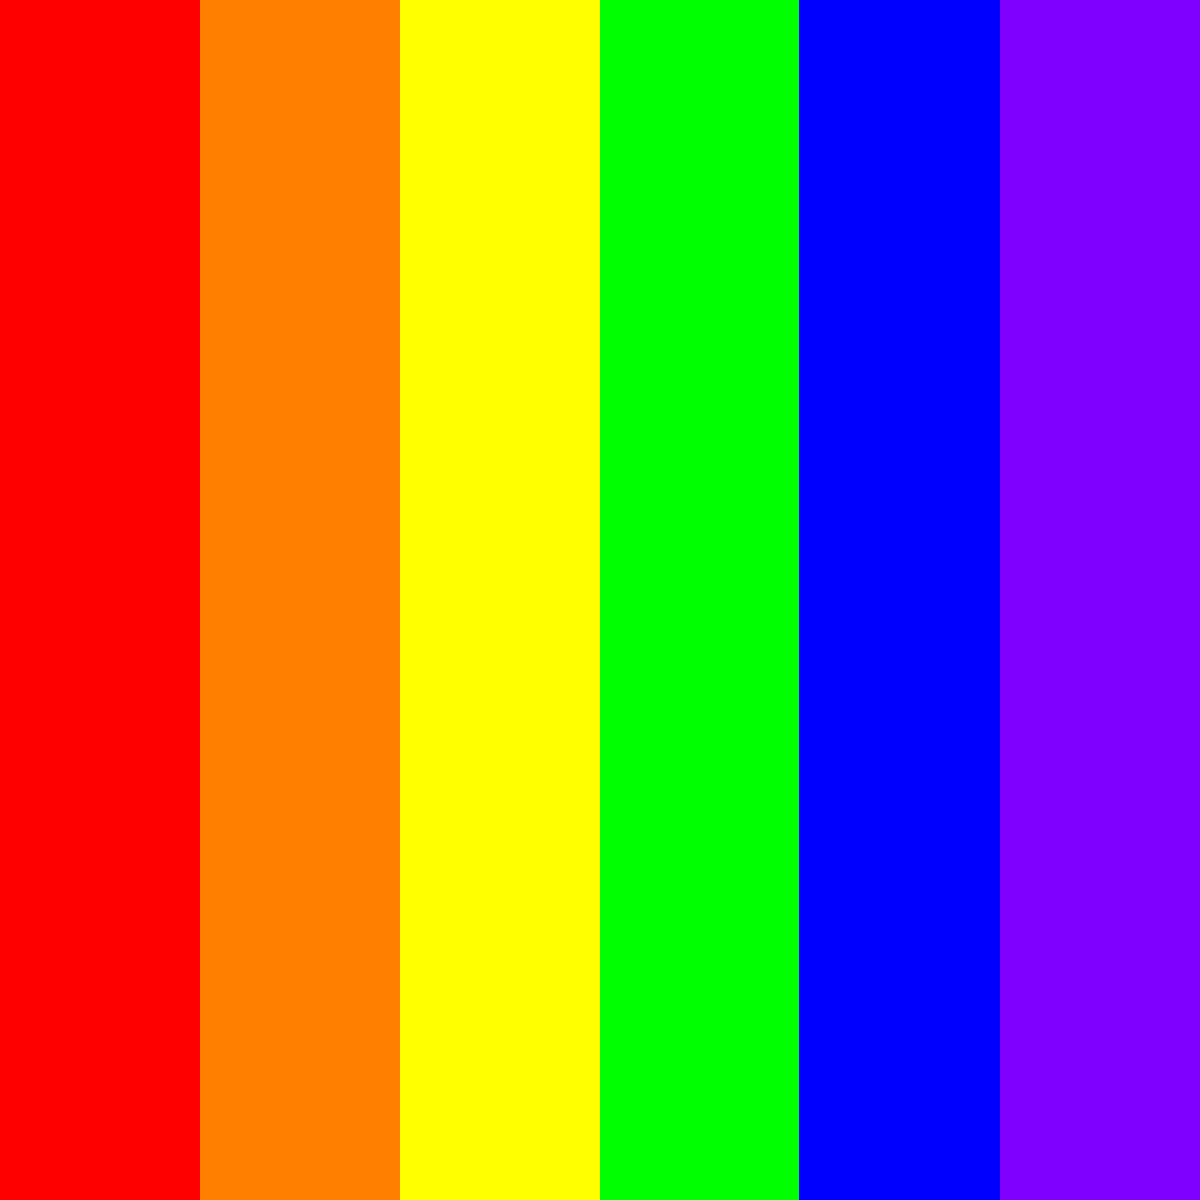In this vibrantly colored heat exchanger diagram, how does the thermal gradient relate to the pop art-inspired color scheme? Explain the relationship between color transitions and heat transfer efficiency. To understand the relationship between the color scheme and thermal gradient in this pop art-inspired heat exchanger diagram:

1. Color representation:
   - The colors transition from red (hot) to purple (cold)
   - Each color represents a temperature range in the heat exchanger

2. Thermal gradient analysis:
   - The diagram shows a continuous color spectrum, implying a smooth temperature transition
   - The gradient moves from left (hot) to right (cold)

3. Heat transfer efficiency:
   - More color bands indicate a larger temperature difference between hot and cold sides
   - A larger temperature difference generally leads to more efficient heat transfer

4. Pop art influence:
   - The use of bold, vibrant colors is characteristic of pop art
   - The distinct color bands create a visually striking representation of the thermal gradient

5. Efficiency interpretation:
   - Smooth color transitions suggest efficient heat transfer with minimal thermal resistance
   - Abrupt color changes would indicate potential areas of inefficiency or thermal barriers

In this case, the smooth transition through six distinct colors (red, orange, yellow, green, blue, purple) suggests a well-designed heat exchanger with efficient heat transfer characteristics.
Answer: The color transitions from red to purple represent decreasing temperatures, with smooth gradients indicating efficient heat transfer in the pop art-inspired heat exchanger design. 